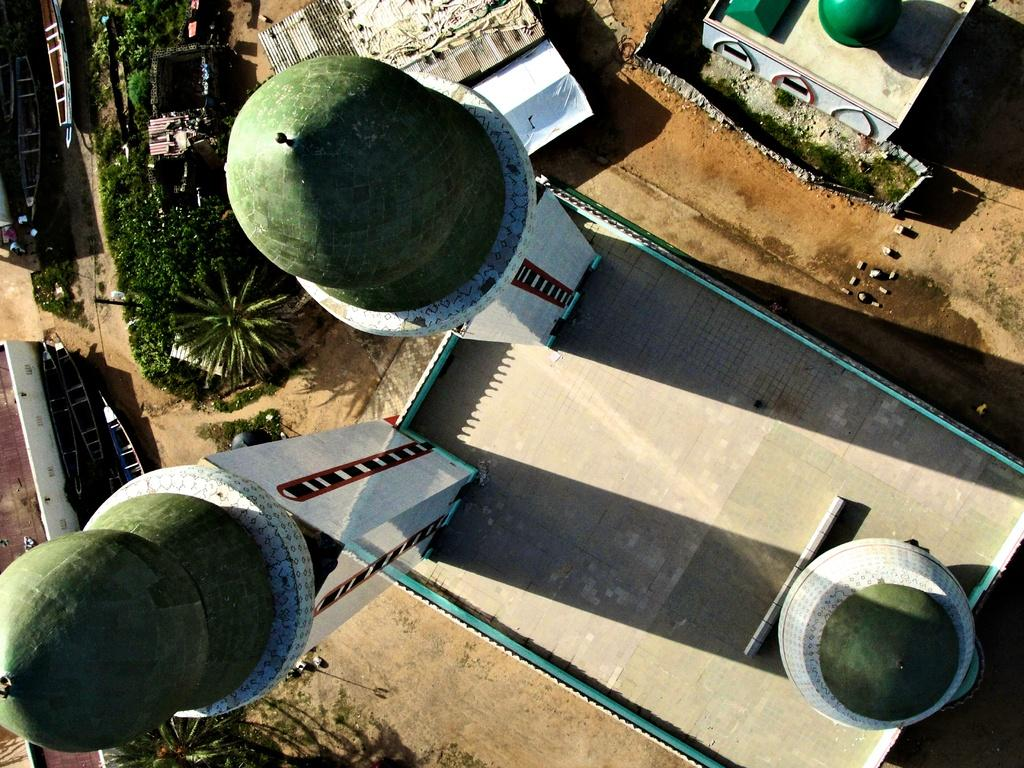How many towers can be seen in the image? There are three towers in the image. What type of building is depicted in the image? The image appears to depict a mosque. Are there any natural elements visible in the image? Yes, there are plants visible in the image. What type of prose is being recited in the image? There is no indication of any prose being recited in the image. Can you see any cactus plants in the image? There are no cactus plants visible in the image; only plants in general are mentioned. 